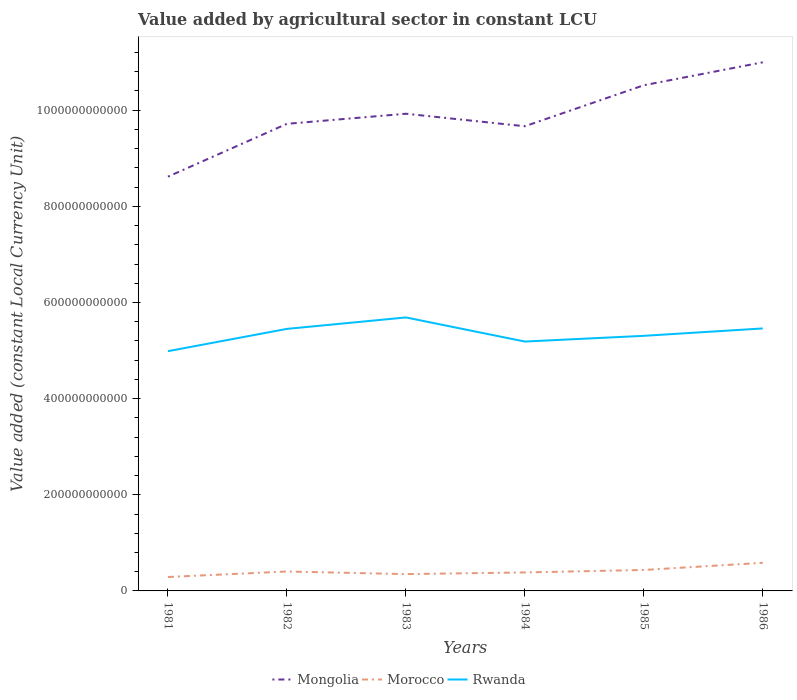Is the number of lines equal to the number of legend labels?
Your answer should be very brief. Yes. Across all years, what is the maximum value added by agricultural sector in Mongolia?
Keep it short and to the point. 8.62e+11. In which year was the value added by agricultural sector in Mongolia maximum?
Make the answer very short. 1981. What is the total value added by agricultural sector in Rwanda in the graph?
Your answer should be very brief. -1.54e+1. What is the difference between the highest and the second highest value added by agricultural sector in Rwanda?
Provide a short and direct response. 7.02e+1. What is the difference between the highest and the lowest value added by agricultural sector in Morocco?
Make the answer very short. 2. How many lines are there?
Keep it short and to the point. 3. How many years are there in the graph?
Provide a short and direct response. 6. What is the difference between two consecutive major ticks on the Y-axis?
Make the answer very short. 2.00e+11. Does the graph contain grids?
Provide a succinct answer. No. Where does the legend appear in the graph?
Your response must be concise. Bottom center. How many legend labels are there?
Your response must be concise. 3. What is the title of the graph?
Ensure brevity in your answer.  Value added by agricultural sector in constant LCU. Does "Low & middle income" appear as one of the legend labels in the graph?
Your answer should be very brief. No. What is the label or title of the X-axis?
Your answer should be compact. Years. What is the label or title of the Y-axis?
Offer a very short reply. Value added (constant Local Currency Unit). What is the Value added (constant Local Currency Unit) of Mongolia in 1981?
Give a very brief answer. 8.62e+11. What is the Value added (constant Local Currency Unit) in Morocco in 1981?
Your response must be concise. 2.90e+1. What is the Value added (constant Local Currency Unit) of Rwanda in 1981?
Ensure brevity in your answer.  4.99e+11. What is the Value added (constant Local Currency Unit) in Mongolia in 1982?
Make the answer very short. 9.72e+11. What is the Value added (constant Local Currency Unit) of Morocco in 1982?
Give a very brief answer. 4.04e+1. What is the Value added (constant Local Currency Unit) in Rwanda in 1982?
Ensure brevity in your answer.  5.45e+11. What is the Value added (constant Local Currency Unit) in Mongolia in 1983?
Keep it short and to the point. 9.93e+11. What is the Value added (constant Local Currency Unit) of Morocco in 1983?
Give a very brief answer. 3.50e+1. What is the Value added (constant Local Currency Unit) of Rwanda in 1983?
Offer a very short reply. 5.69e+11. What is the Value added (constant Local Currency Unit) in Mongolia in 1984?
Keep it short and to the point. 9.67e+11. What is the Value added (constant Local Currency Unit) of Morocco in 1984?
Offer a very short reply. 3.84e+1. What is the Value added (constant Local Currency Unit) in Rwanda in 1984?
Your answer should be very brief. 5.19e+11. What is the Value added (constant Local Currency Unit) in Mongolia in 1985?
Provide a short and direct response. 1.05e+12. What is the Value added (constant Local Currency Unit) of Morocco in 1985?
Your response must be concise. 4.36e+1. What is the Value added (constant Local Currency Unit) in Rwanda in 1985?
Give a very brief answer. 5.31e+11. What is the Value added (constant Local Currency Unit) in Mongolia in 1986?
Make the answer very short. 1.10e+12. What is the Value added (constant Local Currency Unit) in Morocco in 1986?
Your answer should be very brief. 5.85e+1. What is the Value added (constant Local Currency Unit) in Rwanda in 1986?
Keep it short and to the point. 5.46e+11. Across all years, what is the maximum Value added (constant Local Currency Unit) in Mongolia?
Your response must be concise. 1.10e+12. Across all years, what is the maximum Value added (constant Local Currency Unit) of Morocco?
Provide a succinct answer. 5.85e+1. Across all years, what is the maximum Value added (constant Local Currency Unit) in Rwanda?
Your answer should be compact. 5.69e+11. Across all years, what is the minimum Value added (constant Local Currency Unit) in Mongolia?
Your answer should be compact. 8.62e+11. Across all years, what is the minimum Value added (constant Local Currency Unit) of Morocco?
Your response must be concise. 2.90e+1. Across all years, what is the minimum Value added (constant Local Currency Unit) of Rwanda?
Offer a very short reply. 4.99e+11. What is the total Value added (constant Local Currency Unit) in Mongolia in the graph?
Your answer should be very brief. 5.94e+12. What is the total Value added (constant Local Currency Unit) of Morocco in the graph?
Ensure brevity in your answer.  2.45e+11. What is the total Value added (constant Local Currency Unit) of Rwanda in the graph?
Your answer should be compact. 3.21e+12. What is the difference between the Value added (constant Local Currency Unit) of Mongolia in 1981 and that in 1982?
Ensure brevity in your answer.  -1.10e+11. What is the difference between the Value added (constant Local Currency Unit) of Morocco in 1981 and that in 1982?
Ensure brevity in your answer.  -1.14e+1. What is the difference between the Value added (constant Local Currency Unit) of Rwanda in 1981 and that in 1982?
Provide a succinct answer. -4.64e+1. What is the difference between the Value added (constant Local Currency Unit) of Mongolia in 1981 and that in 1983?
Give a very brief answer. -1.31e+11. What is the difference between the Value added (constant Local Currency Unit) in Morocco in 1981 and that in 1983?
Provide a short and direct response. -6.02e+09. What is the difference between the Value added (constant Local Currency Unit) in Rwanda in 1981 and that in 1983?
Your response must be concise. -7.02e+1. What is the difference between the Value added (constant Local Currency Unit) of Mongolia in 1981 and that in 1984?
Provide a short and direct response. -1.05e+11. What is the difference between the Value added (constant Local Currency Unit) of Morocco in 1981 and that in 1984?
Ensure brevity in your answer.  -9.46e+09. What is the difference between the Value added (constant Local Currency Unit) of Rwanda in 1981 and that in 1984?
Offer a very short reply. -2.00e+1. What is the difference between the Value added (constant Local Currency Unit) in Mongolia in 1981 and that in 1985?
Provide a succinct answer. -1.90e+11. What is the difference between the Value added (constant Local Currency Unit) of Morocco in 1981 and that in 1985?
Your answer should be very brief. -1.46e+1. What is the difference between the Value added (constant Local Currency Unit) in Rwanda in 1981 and that in 1985?
Ensure brevity in your answer.  -3.19e+1. What is the difference between the Value added (constant Local Currency Unit) of Mongolia in 1981 and that in 1986?
Provide a short and direct response. -2.38e+11. What is the difference between the Value added (constant Local Currency Unit) of Morocco in 1981 and that in 1986?
Your answer should be compact. -2.95e+1. What is the difference between the Value added (constant Local Currency Unit) in Rwanda in 1981 and that in 1986?
Provide a short and direct response. -4.73e+1. What is the difference between the Value added (constant Local Currency Unit) of Mongolia in 1982 and that in 1983?
Provide a short and direct response. -2.10e+1. What is the difference between the Value added (constant Local Currency Unit) of Morocco in 1982 and that in 1983?
Your response must be concise. 5.42e+09. What is the difference between the Value added (constant Local Currency Unit) of Rwanda in 1982 and that in 1983?
Your response must be concise. -2.38e+1. What is the difference between the Value added (constant Local Currency Unit) of Mongolia in 1982 and that in 1984?
Make the answer very short. 5.06e+09. What is the difference between the Value added (constant Local Currency Unit) of Morocco in 1982 and that in 1984?
Ensure brevity in your answer.  1.98e+09. What is the difference between the Value added (constant Local Currency Unit) in Rwanda in 1982 and that in 1984?
Your response must be concise. 2.63e+1. What is the difference between the Value added (constant Local Currency Unit) in Mongolia in 1982 and that in 1985?
Your answer should be very brief. -8.02e+1. What is the difference between the Value added (constant Local Currency Unit) in Morocco in 1982 and that in 1985?
Provide a short and direct response. -3.18e+09. What is the difference between the Value added (constant Local Currency Unit) in Rwanda in 1982 and that in 1985?
Provide a short and direct response. 1.45e+1. What is the difference between the Value added (constant Local Currency Unit) in Mongolia in 1982 and that in 1986?
Your answer should be compact. -1.28e+11. What is the difference between the Value added (constant Local Currency Unit) of Morocco in 1982 and that in 1986?
Provide a succinct answer. -1.81e+1. What is the difference between the Value added (constant Local Currency Unit) of Rwanda in 1982 and that in 1986?
Offer a very short reply. -9.36e+08. What is the difference between the Value added (constant Local Currency Unit) in Mongolia in 1983 and that in 1984?
Offer a terse response. 2.60e+1. What is the difference between the Value added (constant Local Currency Unit) in Morocco in 1983 and that in 1984?
Keep it short and to the point. -3.44e+09. What is the difference between the Value added (constant Local Currency Unit) in Rwanda in 1983 and that in 1984?
Offer a terse response. 5.02e+1. What is the difference between the Value added (constant Local Currency Unit) in Mongolia in 1983 and that in 1985?
Provide a succinct answer. -5.93e+1. What is the difference between the Value added (constant Local Currency Unit) of Morocco in 1983 and that in 1985?
Your answer should be very brief. -8.60e+09. What is the difference between the Value added (constant Local Currency Unit) in Rwanda in 1983 and that in 1985?
Keep it short and to the point. 3.83e+1. What is the difference between the Value added (constant Local Currency Unit) in Mongolia in 1983 and that in 1986?
Give a very brief answer. -1.07e+11. What is the difference between the Value added (constant Local Currency Unit) of Morocco in 1983 and that in 1986?
Provide a succinct answer. -2.35e+1. What is the difference between the Value added (constant Local Currency Unit) of Rwanda in 1983 and that in 1986?
Provide a succinct answer. 2.29e+1. What is the difference between the Value added (constant Local Currency Unit) of Mongolia in 1984 and that in 1985?
Ensure brevity in your answer.  -8.53e+1. What is the difference between the Value added (constant Local Currency Unit) in Morocco in 1984 and that in 1985?
Give a very brief answer. -5.16e+09. What is the difference between the Value added (constant Local Currency Unit) in Rwanda in 1984 and that in 1985?
Give a very brief answer. -1.19e+1. What is the difference between the Value added (constant Local Currency Unit) in Mongolia in 1984 and that in 1986?
Your answer should be compact. -1.33e+11. What is the difference between the Value added (constant Local Currency Unit) in Morocco in 1984 and that in 1986?
Make the answer very short. -2.01e+1. What is the difference between the Value added (constant Local Currency Unit) of Rwanda in 1984 and that in 1986?
Provide a succinct answer. -2.73e+1. What is the difference between the Value added (constant Local Currency Unit) of Mongolia in 1985 and that in 1986?
Provide a short and direct response. -4.77e+1. What is the difference between the Value added (constant Local Currency Unit) of Morocco in 1985 and that in 1986?
Offer a terse response. -1.49e+1. What is the difference between the Value added (constant Local Currency Unit) in Rwanda in 1985 and that in 1986?
Your answer should be compact. -1.54e+1. What is the difference between the Value added (constant Local Currency Unit) in Mongolia in 1981 and the Value added (constant Local Currency Unit) in Morocco in 1982?
Offer a terse response. 8.21e+11. What is the difference between the Value added (constant Local Currency Unit) of Mongolia in 1981 and the Value added (constant Local Currency Unit) of Rwanda in 1982?
Offer a very short reply. 3.17e+11. What is the difference between the Value added (constant Local Currency Unit) in Morocco in 1981 and the Value added (constant Local Currency Unit) in Rwanda in 1982?
Your answer should be very brief. -5.16e+11. What is the difference between the Value added (constant Local Currency Unit) in Mongolia in 1981 and the Value added (constant Local Currency Unit) in Morocco in 1983?
Your response must be concise. 8.27e+11. What is the difference between the Value added (constant Local Currency Unit) in Mongolia in 1981 and the Value added (constant Local Currency Unit) in Rwanda in 1983?
Keep it short and to the point. 2.93e+11. What is the difference between the Value added (constant Local Currency Unit) of Morocco in 1981 and the Value added (constant Local Currency Unit) of Rwanda in 1983?
Make the answer very short. -5.40e+11. What is the difference between the Value added (constant Local Currency Unit) in Mongolia in 1981 and the Value added (constant Local Currency Unit) in Morocco in 1984?
Provide a short and direct response. 8.23e+11. What is the difference between the Value added (constant Local Currency Unit) of Mongolia in 1981 and the Value added (constant Local Currency Unit) of Rwanda in 1984?
Ensure brevity in your answer.  3.43e+11. What is the difference between the Value added (constant Local Currency Unit) in Morocco in 1981 and the Value added (constant Local Currency Unit) in Rwanda in 1984?
Provide a short and direct response. -4.90e+11. What is the difference between the Value added (constant Local Currency Unit) in Mongolia in 1981 and the Value added (constant Local Currency Unit) in Morocco in 1985?
Your answer should be compact. 8.18e+11. What is the difference between the Value added (constant Local Currency Unit) of Mongolia in 1981 and the Value added (constant Local Currency Unit) of Rwanda in 1985?
Ensure brevity in your answer.  3.31e+11. What is the difference between the Value added (constant Local Currency Unit) in Morocco in 1981 and the Value added (constant Local Currency Unit) in Rwanda in 1985?
Give a very brief answer. -5.02e+11. What is the difference between the Value added (constant Local Currency Unit) in Mongolia in 1981 and the Value added (constant Local Currency Unit) in Morocco in 1986?
Offer a very short reply. 8.03e+11. What is the difference between the Value added (constant Local Currency Unit) of Mongolia in 1981 and the Value added (constant Local Currency Unit) of Rwanda in 1986?
Offer a very short reply. 3.16e+11. What is the difference between the Value added (constant Local Currency Unit) in Morocco in 1981 and the Value added (constant Local Currency Unit) in Rwanda in 1986?
Your answer should be compact. -5.17e+11. What is the difference between the Value added (constant Local Currency Unit) in Mongolia in 1982 and the Value added (constant Local Currency Unit) in Morocco in 1983?
Keep it short and to the point. 9.37e+11. What is the difference between the Value added (constant Local Currency Unit) in Mongolia in 1982 and the Value added (constant Local Currency Unit) in Rwanda in 1983?
Your response must be concise. 4.03e+11. What is the difference between the Value added (constant Local Currency Unit) of Morocco in 1982 and the Value added (constant Local Currency Unit) of Rwanda in 1983?
Keep it short and to the point. -5.28e+11. What is the difference between the Value added (constant Local Currency Unit) of Mongolia in 1982 and the Value added (constant Local Currency Unit) of Morocco in 1984?
Offer a very short reply. 9.33e+11. What is the difference between the Value added (constant Local Currency Unit) in Mongolia in 1982 and the Value added (constant Local Currency Unit) in Rwanda in 1984?
Offer a terse response. 4.53e+11. What is the difference between the Value added (constant Local Currency Unit) of Morocco in 1982 and the Value added (constant Local Currency Unit) of Rwanda in 1984?
Your answer should be compact. -4.78e+11. What is the difference between the Value added (constant Local Currency Unit) of Mongolia in 1982 and the Value added (constant Local Currency Unit) of Morocco in 1985?
Provide a succinct answer. 9.28e+11. What is the difference between the Value added (constant Local Currency Unit) in Mongolia in 1982 and the Value added (constant Local Currency Unit) in Rwanda in 1985?
Keep it short and to the point. 4.41e+11. What is the difference between the Value added (constant Local Currency Unit) in Morocco in 1982 and the Value added (constant Local Currency Unit) in Rwanda in 1985?
Your answer should be compact. -4.90e+11. What is the difference between the Value added (constant Local Currency Unit) in Mongolia in 1982 and the Value added (constant Local Currency Unit) in Morocco in 1986?
Ensure brevity in your answer.  9.13e+11. What is the difference between the Value added (constant Local Currency Unit) in Mongolia in 1982 and the Value added (constant Local Currency Unit) in Rwanda in 1986?
Offer a very short reply. 4.26e+11. What is the difference between the Value added (constant Local Currency Unit) of Morocco in 1982 and the Value added (constant Local Currency Unit) of Rwanda in 1986?
Your response must be concise. -5.06e+11. What is the difference between the Value added (constant Local Currency Unit) of Mongolia in 1983 and the Value added (constant Local Currency Unit) of Morocco in 1984?
Provide a short and direct response. 9.54e+11. What is the difference between the Value added (constant Local Currency Unit) in Mongolia in 1983 and the Value added (constant Local Currency Unit) in Rwanda in 1984?
Give a very brief answer. 4.74e+11. What is the difference between the Value added (constant Local Currency Unit) of Morocco in 1983 and the Value added (constant Local Currency Unit) of Rwanda in 1984?
Provide a short and direct response. -4.84e+11. What is the difference between the Value added (constant Local Currency Unit) in Mongolia in 1983 and the Value added (constant Local Currency Unit) in Morocco in 1985?
Ensure brevity in your answer.  9.49e+11. What is the difference between the Value added (constant Local Currency Unit) in Mongolia in 1983 and the Value added (constant Local Currency Unit) in Rwanda in 1985?
Your response must be concise. 4.62e+11. What is the difference between the Value added (constant Local Currency Unit) of Morocco in 1983 and the Value added (constant Local Currency Unit) of Rwanda in 1985?
Offer a very short reply. -4.96e+11. What is the difference between the Value added (constant Local Currency Unit) in Mongolia in 1983 and the Value added (constant Local Currency Unit) in Morocco in 1986?
Your answer should be compact. 9.34e+11. What is the difference between the Value added (constant Local Currency Unit) of Mongolia in 1983 and the Value added (constant Local Currency Unit) of Rwanda in 1986?
Offer a terse response. 4.47e+11. What is the difference between the Value added (constant Local Currency Unit) of Morocco in 1983 and the Value added (constant Local Currency Unit) of Rwanda in 1986?
Make the answer very short. -5.11e+11. What is the difference between the Value added (constant Local Currency Unit) of Mongolia in 1984 and the Value added (constant Local Currency Unit) of Morocco in 1985?
Make the answer very short. 9.23e+11. What is the difference between the Value added (constant Local Currency Unit) in Mongolia in 1984 and the Value added (constant Local Currency Unit) in Rwanda in 1985?
Offer a very short reply. 4.36e+11. What is the difference between the Value added (constant Local Currency Unit) of Morocco in 1984 and the Value added (constant Local Currency Unit) of Rwanda in 1985?
Offer a terse response. -4.92e+11. What is the difference between the Value added (constant Local Currency Unit) in Mongolia in 1984 and the Value added (constant Local Currency Unit) in Morocco in 1986?
Ensure brevity in your answer.  9.08e+11. What is the difference between the Value added (constant Local Currency Unit) of Mongolia in 1984 and the Value added (constant Local Currency Unit) of Rwanda in 1986?
Make the answer very short. 4.21e+11. What is the difference between the Value added (constant Local Currency Unit) of Morocco in 1984 and the Value added (constant Local Currency Unit) of Rwanda in 1986?
Offer a very short reply. -5.08e+11. What is the difference between the Value added (constant Local Currency Unit) in Mongolia in 1985 and the Value added (constant Local Currency Unit) in Morocco in 1986?
Your answer should be very brief. 9.93e+11. What is the difference between the Value added (constant Local Currency Unit) in Mongolia in 1985 and the Value added (constant Local Currency Unit) in Rwanda in 1986?
Ensure brevity in your answer.  5.06e+11. What is the difference between the Value added (constant Local Currency Unit) in Morocco in 1985 and the Value added (constant Local Currency Unit) in Rwanda in 1986?
Give a very brief answer. -5.02e+11. What is the average Value added (constant Local Currency Unit) in Mongolia per year?
Your answer should be very brief. 9.91e+11. What is the average Value added (constant Local Currency Unit) in Morocco per year?
Make the answer very short. 4.08e+1. What is the average Value added (constant Local Currency Unit) in Rwanda per year?
Your response must be concise. 5.35e+11. In the year 1981, what is the difference between the Value added (constant Local Currency Unit) in Mongolia and Value added (constant Local Currency Unit) in Morocco?
Ensure brevity in your answer.  8.33e+11. In the year 1981, what is the difference between the Value added (constant Local Currency Unit) of Mongolia and Value added (constant Local Currency Unit) of Rwanda?
Provide a succinct answer. 3.63e+11. In the year 1981, what is the difference between the Value added (constant Local Currency Unit) in Morocco and Value added (constant Local Currency Unit) in Rwanda?
Give a very brief answer. -4.70e+11. In the year 1982, what is the difference between the Value added (constant Local Currency Unit) of Mongolia and Value added (constant Local Currency Unit) of Morocco?
Provide a succinct answer. 9.31e+11. In the year 1982, what is the difference between the Value added (constant Local Currency Unit) in Mongolia and Value added (constant Local Currency Unit) in Rwanda?
Your response must be concise. 4.27e+11. In the year 1982, what is the difference between the Value added (constant Local Currency Unit) of Morocco and Value added (constant Local Currency Unit) of Rwanda?
Your answer should be very brief. -5.05e+11. In the year 1983, what is the difference between the Value added (constant Local Currency Unit) of Mongolia and Value added (constant Local Currency Unit) of Morocco?
Make the answer very short. 9.58e+11. In the year 1983, what is the difference between the Value added (constant Local Currency Unit) of Mongolia and Value added (constant Local Currency Unit) of Rwanda?
Offer a terse response. 4.24e+11. In the year 1983, what is the difference between the Value added (constant Local Currency Unit) of Morocco and Value added (constant Local Currency Unit) of Rwanda?
Keep it short and to the point. -5.34e+11. In the year 1984, what is the difference between the Value added (constant Local Currency Unit) in Mongolia and Value added (constant Local Currency Unit) in Morocco?
Offer a very short reply. 9.28e+11. In the year 1984, what is the difference between the Value added (constant Local Currency Unit) of Mongolia and Value added (constant Local Currency Unit) of Rwanda?
Offer a terse response. 4.48e+11. In the year 1984, what is the difference between the Value added (constant Local Currency Unit) of Morocco and Value added (constant Local Currency Unit) of Rwanda?
Provide a short and direct response. -4.80e+11. In the year 1985, what is the difference between the Value added (constant Local Currency Unit) of Mongolia and Value added (constant Local Currency Unit) of Morocco?
Your response must be concise. 1.01e+12. In the year 1985, what is the difference between the Value added (constant Local Currency Unit) of Mongolia and Value added (constant Local Currency Unit) of Rwanda?
Your answer should be very brief. 5.21e+11. In the year 1985, what is the difference between the Value added (constant Local Currency Unit) of Morocco and Value added (constant Local Currency Unit) of Rwanda?
Provide a short and direct response. -4.87e+11. In the year 1986, what is the difference between the Value added (constant Local Currency Unit) in Mongolia and Value added (constant Local Currency Unit) in Morocco?
Ensure brevity in your answer.  1.04e+12. In the year 1986, what is the difference between the Value added (constant Local Currency Unit) in Mongolia and Value added (constant Local Currency Unit) in Rwanda?
Keep it short and to the point. 5.54e+11. In the year 1986, what is the difference between the Value added (constant Local Currency Unit) in Morocco and Value added (constant Local Currency Unit) in Rwanda?
Keep it short and to the point. -4.88e+11. What is the ratio of the Value added (constant Local Currency Unit) of Mongolia in 1981 to that in 1982?
Give a very brief answer. 0.89. What is the ratio of the Value added (constant Local Currency Unit) of Morocco in 1981 to that in 1982?
Your answer should be compact. 0.72. What is the ratio of the Value added (constant Local Currency Unit) of Rwanda in 1981 to that in 1982?
Make the answer very short. 0.91. What is the ratio of the Value added (constant Local Currency Unit) in Mongolia in 1981 to that in 1983?
Give a very brief answer. 0.87. What is the ratio of the Value added (constant Local Currency Unit) of Morocco in 1981 to that in 1983?
Make the answer very short. 0.83. What is the ratio of the Value added (constant Local Currency Unit) in Rwanda in 1981 to that in 1983?
Your response must be concise. 0.88. What is the ratio of the Value added (constant Local Currency Unit) in Mongolia in 1981 to that in 1984?
Your response must be concise. 0.89. What is the ratio of the Value added (constant Local Currency Unit) in Morocco in 1981 to that in 1984?
Offer a terse response. 0.75. What is the ratio of the Value added (constant Local Currency Unit) of Rwanda in 1981 to that in 1984?
Give a very brief answer. 0.96. What is the ratio of the Value added (constant Local Currency Unit) of Mongolia in 1981 to that in 1985?
Offer a terse response. 0.82. What is the ratio of the Value added (constant Local Currency Unit) in Morocco in 1981 to that in 1985?
Give a very brief answer. 0.66. What is the ratio of the Value added (constant Local Currency Unit) in Rwanda in 1981 to that in 1985?
Provide a succinct answer. 0.94. What is the ratio of the Value added (constant Local Currency Unit) in Mongolia in 1981 to that in 1986?
Offer a very short reply. 0.78. What is the ratio of the Value added (constant Local Currency Unit) of Morocco in 1981 to that in 1986?
Keep it short and to the point. 0.5. What is the ratio of the Value added (constant Local Currency Unit) in Rwanda in 1981 to that in 1986?
Provide a short and direct response. 0.91. What is the ratio of the Value added (constant Local Currency Unit) in Mongolia in 1982 to that in 1983?
Provide a succinct answer. 0.98. What is the ratio of the Value added (constant Local Currency Unit) of Morocco in 1982 to that in 1983?
Offer a terse response. 1.15. What is the ratio of the Value added (constant Local Currency Unit) in Rwanda in 1982 to that in 1983?
Offer a very short reply. 0.96. What is the ratio of the Value added (constant Local Currency Unit) of Morocco in 1982 to that in 1984?
Your response must be concise. 1.05. What is the ratio of the Value added (constant Local Currency Unit) of Rwanda in 1982 to that in 1984?
Offer a very short reply. 1.05. What is the ratio of the Value added (constant Local Currency Unit) in Mongolia in 1982 to that in 1985?
Keep it short and to the point. 0.92. What is the ratio of the Value added (constant Local Currency Unit) of Morocco in 1982 to that in 1985?
Give a very brief answer. 0.93. What is the ratio of the Value added (constant Local Currency Unit) of Rwanda in 1982 to that in 1985?
Provide a succinct answer. 1.03. What is the ratio of the Value added (constant Local Currency Unit) in Mongolia in 1982 to that in 1986?
Offer a terse response. 0.88. What is the ratio of the Value added (constant Local Currency Unit) in Morocco in 1982 to that in 1986?
Ensure brevity in your answer.  0.69. What is the ratio of the Value added (constant Local Currency Unit) in Mongolia in 1983 to that in 1984?
Your answer should be compact. 1.03. What is the ratio of the Value added (constant Local Currency Unit) in Morocco in 1983 to that in 1984?
Keep it short and to the point. 0.91. What is the ratio of the Value added (constant Local Currency Unit) in Rwanda in 1983 to that in 1984?
Give a very brief answer. 1.1. What is the ratio of the Value added (constant Local Currency Unit) of Mongolia in 1983 to that in 1985?
Keep it short and to the point. 0.94. What is the ratio of the Value added (constant Local Currency Unit) in Morocco in 1983 to that in 1985?
Your response must be concise. 0.8. What is the ratio of the Value added (constant Local Currency Unit) in Rwanda in 1983 to that in 1985?
Make the answer very short. 1.07. What is the ratio of the Value added (constant Local Currency Unit) of Mongolia in 1983 to that in 1986?
Offer a terse response. 0.9. What is the ratio of the Value added (constant Local Currency Unit) in Morocco in 1983 to that in 1986?
Give a very brief answer. 0.6. What is the ratio of the Value added (constant Local Currency Unit) of Rwanda in 1983 to that in 1986?
Ensure brevity in your answer.  1.04. What is the ratio of the Value added (constant Local Currency Unit) of Mongolia in 1984 to that in 1985?
Provide a short and direct response. 0.92. What is the ratio of the Value added (constant Local Currency Unit) of Morocco in 1984 to that in 1985?
Your answer should be compact. 0.88. What is the ratio of the Value added (constant Local Currency Unit) of Rwanda in 1984 to that in 1985?
Make the answer very short. 0.98. What is the ratio of the Value added (constant Local Currency Unit) of Mongolia in 1984 to that in 1986?
Make the answer very short. 0.88. What is the ratio of the Value added (constant Local Currency Unit) in Morocco in 1984 to that in 1986?
Offer a terse response. 0.66. What is the ratio of the Value added (constant Local Currency Unit) of Mongolia in 1985 to that in 1986?
Ensure brevity in your answer.  0.96. What is the ratio of the Value added (constant Local Currency Unit) of Morocco in 1985 to that in 1986?
Give a very brief answer. 0.75. What is the ratio of the Value added (constant Local Currency Unit) of Rwanda in 1985 to that in 1986?
Your answer should be very brief. 0.97. What is the difference between the highest and the second highest Value added (constant Local Currency Unit) of Mongolia?
Make the answer very short. 4.77e+1. What is the difference between the highest and the second highest Value added (constant Local Currency Unit) of Morocco?
Ensure brevity in your answer.  1.49e+1. What is the difference between the highest and the second highest Value added (constant Local Currency Unit) of Rwanda?
Offer a terse response. 2.29e+1. What is the difference between the highest and the lowest Value added (constant Local Currency Unit) of Mongolia?
Your response must be concise. 2.38e+11. What is the difference between the highest and the lowest Value added (constant Local Currency Unit) in Morocco?
Keep it short and to the point. 2.95e+1. What is the difference between the highest and the lowest Value added (constant Local Currency Unit) of Rwanda?
Keep it short and to the point. 7.02e+1. 